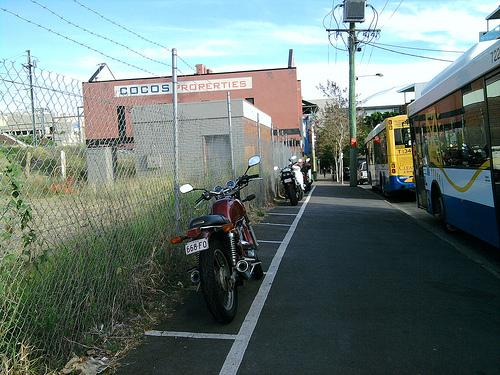Provide a brief overview of the most prominent elements in the image. The image features a red motorcycle parked by a fence, a yellow bus, and a white and blue bus parked on the road, and a two-story building with a white sign. Summarize the key elements of the image in a single sentence. A red motorcycle parked by a fence, a yellow bus, and a white and blue bus are the focus of the image, with a two-story building in the background. Write a caption for the image focusing on interesting aspects of the scene. "Parked Red Motorcycle and Colorful Buses: A Vibrant Street Scene Featuring Various Modes of Transportation" Provide a description of the location in the image, focusing on the environment and nearby objects. The scene takes place on a street with parked vehicles, including a red motorcycle by a fence, a yellow bus, and a white and blue bus, near a two-story building with a white sign. Describe the various colors and objects that can be found in the image. The image has a red motorcycle, a yellow bus, a white and blue bus, green grass, a white sign on a building, a chain-link fence, and a two-story building. Describe the vehicles found in the image and their state. The image shows a red motorcycle parked by a fence, a parked yellow bus, a parked white and blue bus, and a white car in front of the bus. Write a poetic description of the scene captured in the image. Amidst the hum of the city, a vibrant red motorcycle rests by the fence, accompanied by two majestic buses, painting a lively portrait of life on the road. Mention the most visually striking object in the image and its surrounding environment. A red motorcycle stands out as it is parked by a fence, with a yellow and a white and blue bus nearby, beside a chain-link fence and a two-story building. Identify the main type of transportation displayed in the image and any relevant surroundings. Motorcycles and buses are the main forms of transportation, with a red motorcycle parked by a fence, a yellow bus, and a white and blue bus on the road. Narrate the primary aspects of the image, including any unique features. A red motorcycle is parked near a fence, while a yellow bus and a white and blue bus are also parked on the road, and a two-story building with a white sign stands in the background. 